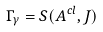<formula> <loc_0><loc_0><loc_500><loc_500>\Gamma _ { \gamma } = S ( A ^ { c l } , J )</formula> 